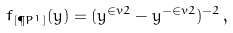Convert formula to latex. <formula><loc_0><loc_0><loc_500><loc_500>f _ { [ \P P ^ { 1 } ] } ( y ) = ( y ^ { \in v { 2 } } - y ^ { - \in v { 2 } } ) ^ { - 2 } \, ,</formula> 